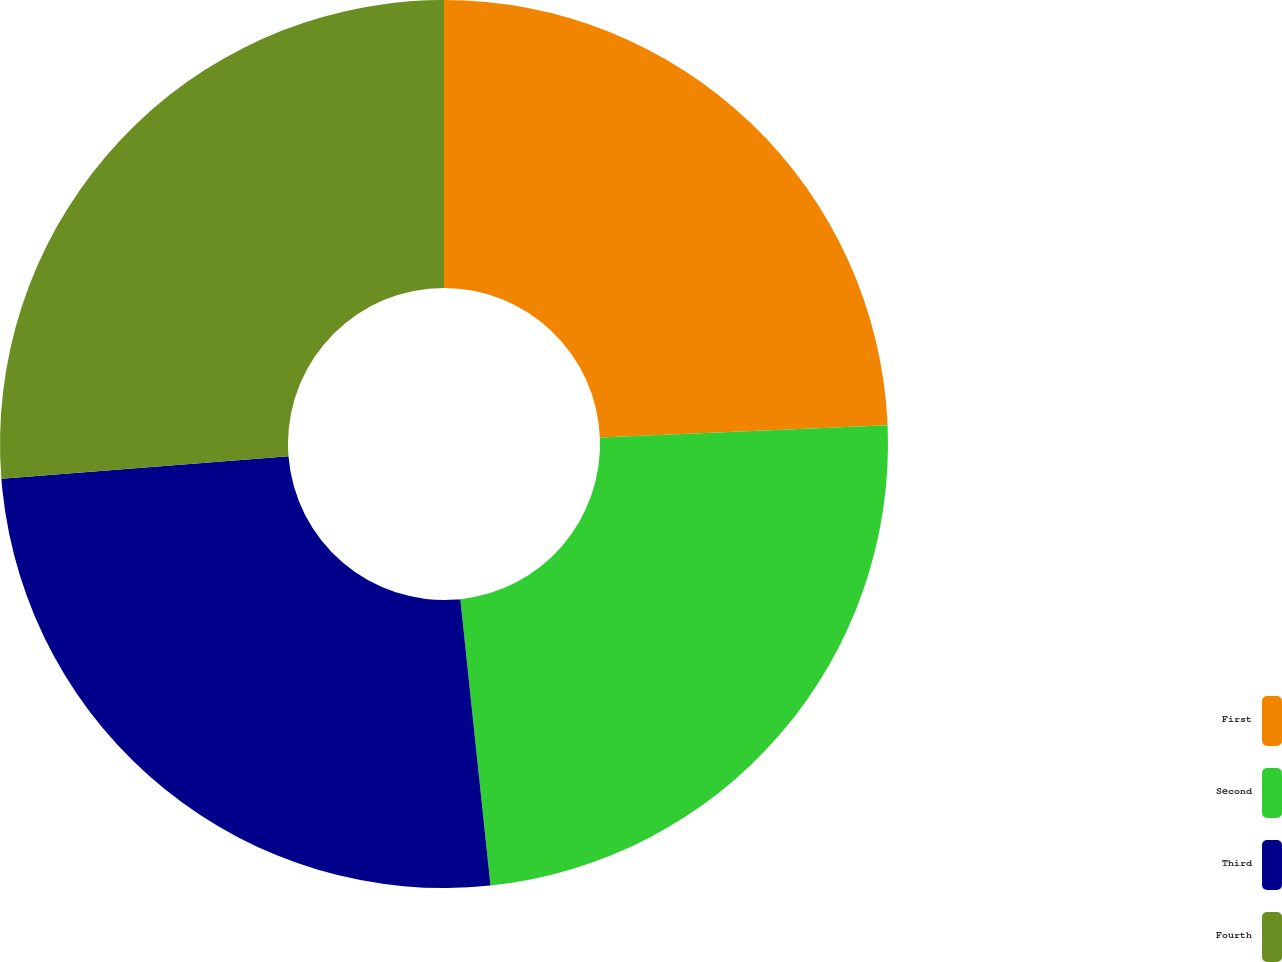Convert chart. <chart><loc_0><loc_0><loc_500><loc_500><pie_chart><fcel>First<fcel>Second<fcel>Third<fcel>Fourth<nl><fcel>24.33%<fcel>24.0%<fcel>25.42%<fcel>26.25%<nl></chart> 